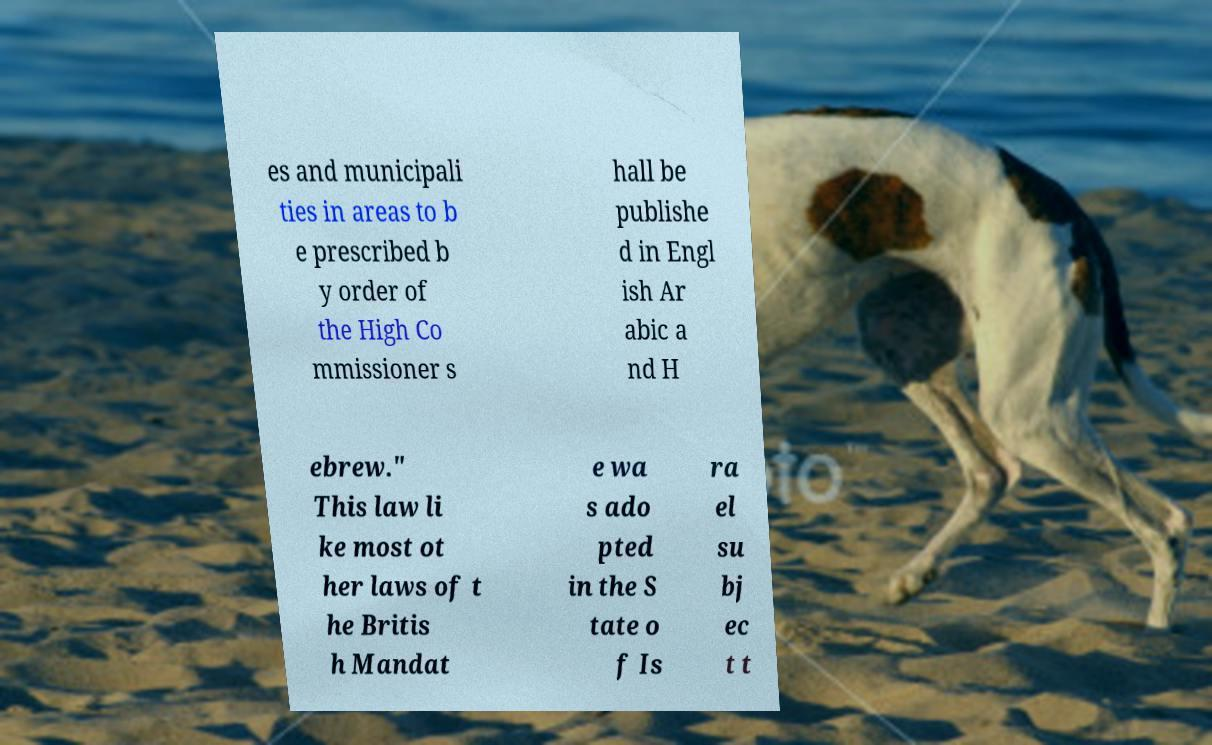What messages or text are displayed in this image? I need them in a readable, typed format. es and municipali ties in areas to b e prescribed b y order of the High Co mmissioner s hall be publishe d in Engl ish Ar abic a nd H ebrew." This law li ke most ot her laws of t he Britis h Mandat e wa s ado pted in the S tate o f Is ra el su bj ec t t 